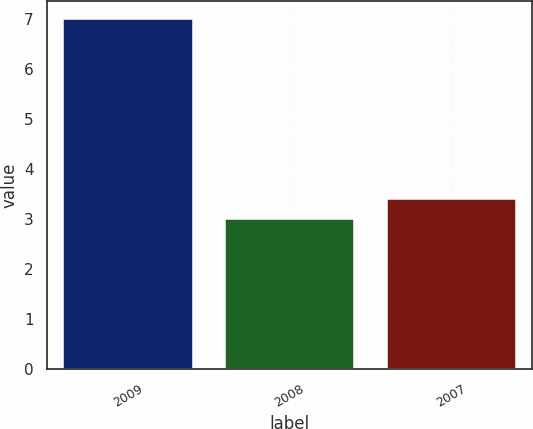<chart> <loc_0><loc_0><loc_500><loc_500><bar_chart><fcel>2009<fcel>2008<fcel>2007<nl><fcel>7<fcel>3<fcel>3.4<nl></chart> 